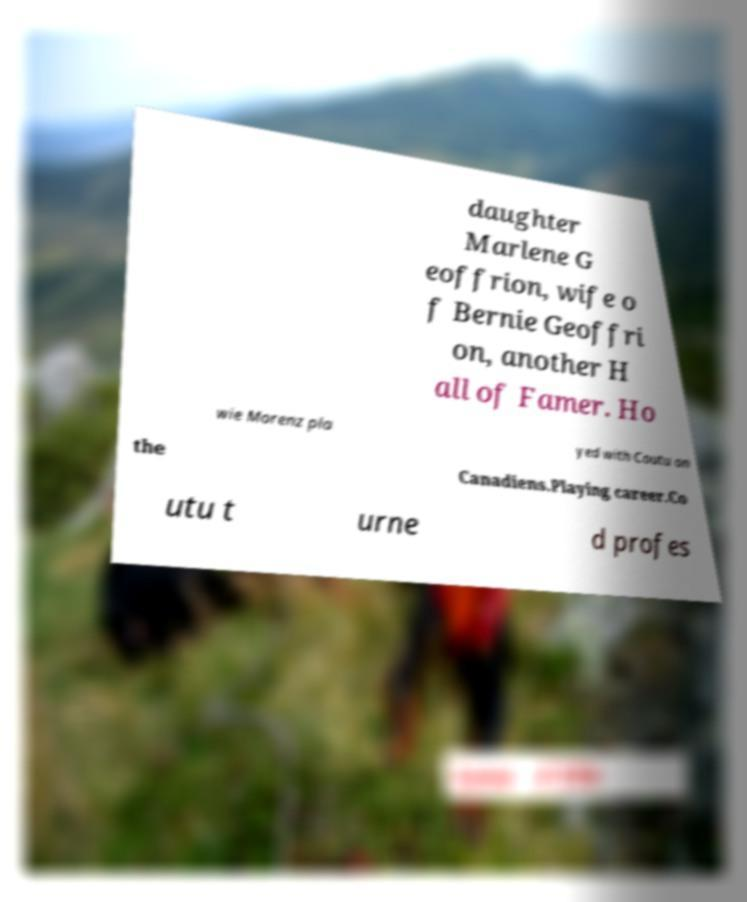Could you extract and type out the text from this image? daughter Marlene G eoffrion, wife o f Bernie Geoffri on, another H all of Famer. Ho wie Morenz pla yed with Coutu on the Canadiens.Playing career.Co utu t urne d profes 